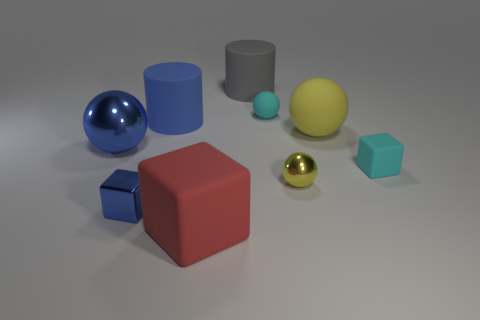What number of matte objects are the same color as the tiny rubber sphere?
Your answer should be very brief. 1. Is the gray object the same shape as the red rubber object?
Keep it short and to the point. No. The red object that is the same shape as the small blue shiny thing is what size?
Your answer should be very brief. Large. Are there more small rubber objects that are to the left of the yellow rubber thing than tiny cyan balls right of the small rubber ball?
Your answer should be very brief. Yes. Is the material of the gray cylinder the same as the large cylinder in front of the large gray cylinder?
Provide a short and direct response. Yes. What is the color of the matte object that is in front of the big yellow object and to the left of the large yellow ball?
Your answer should be very brief. Red. There is a small object that is behind the big yellow rubber sphere; what shape is it?
Ensure brevity in your answer.  Sphere. What size is the blue object right of the blue metal object that is in front of the cyan thing that is right of the yellow rubber sphere?
Your response must be concise. Large. There is a big object to the right of the small yellow metal object; what number of big rubber objects are on the left side of it?
Provide a short and direct response. 3. There is a blue object that is both right of the large blue metallic object and in front of the blue cylinder; what is its size?
Offer a terse response. Small. 